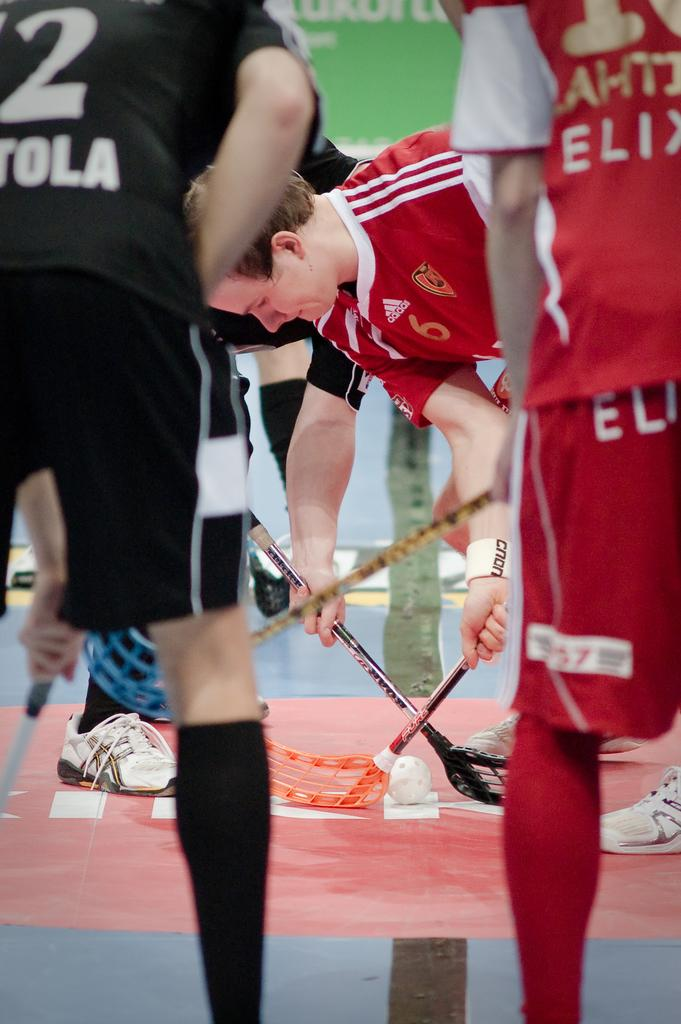<image>
Render a clear and concise summary of the photo. a few soccer players where one has the number 2 